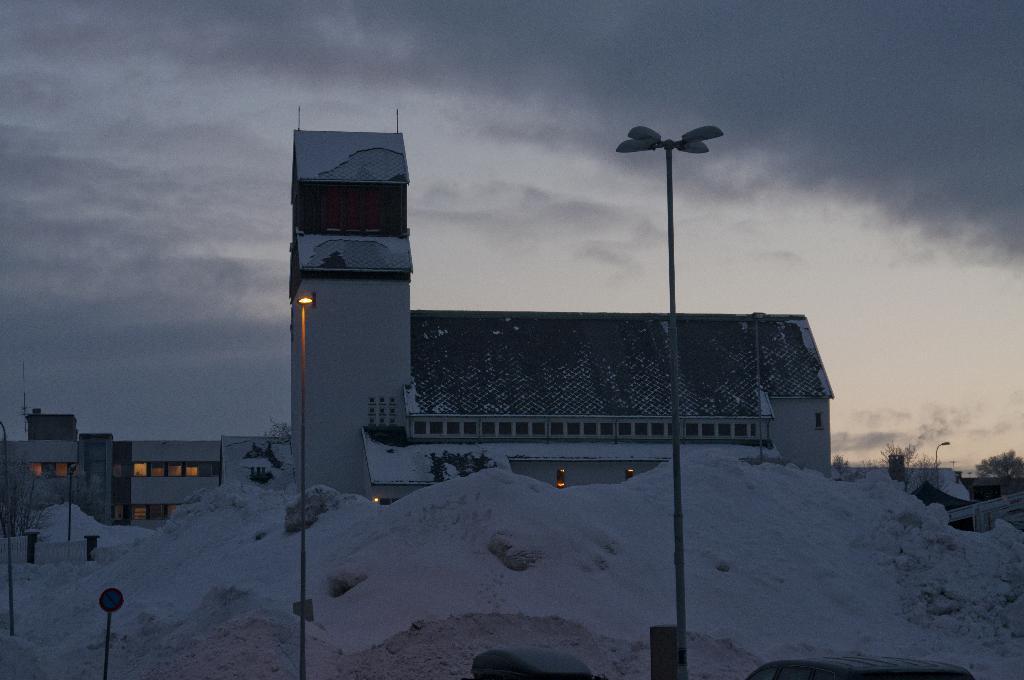How would you summarize this image in a sentence or two? In this image I can see few light poles with lights on top of them, a pole with a sign board, snow on the ground, few trees and few buildings. In the background I can see the sky. 